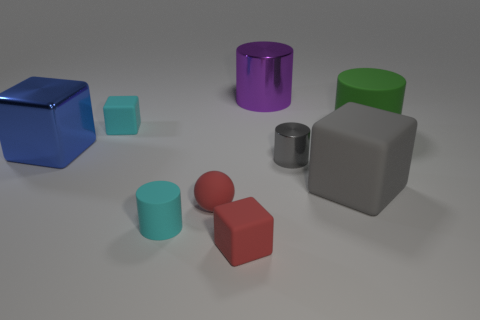Do the small block in front of the tiny shiny cylinder and the rubber block that is on the left side of the cyan cylinder have the same color?
Keep it short and to the point. No. Are there more big purple shiny spheres than cylinders?
Offer a very short reply. No. What number of other big cubes are the same color as the big metallic block?
Provide a short and direct response. 0. What is the color of the big metallic thing that is the same shape as the green rubber object?
Your response must be concise. Purple. The object that is both to the left of the tiny red rubber sphere and behind the big green matte object is made of what material?
Provide a succinct answer. Rubber. Do the small cylinder to the left of the red rubber block and the big thing in front of the gray cylinder have the same material?
Your answer should be compact. Yes. How big is the purple cylinder?
Give a very brief answer. Large. What is the size of the purple metallic object that is the same shape as the gray metal thing?
Offer a terse response. Large. There is a tiny red rubber block; how many small objects are to the left of it?
Ensure brevity in your answer.  3. What is the color of the metal cylinder behind the large cylinder that is in front of the tiny cyan cube?
Keep it short and to the point. Purple. 